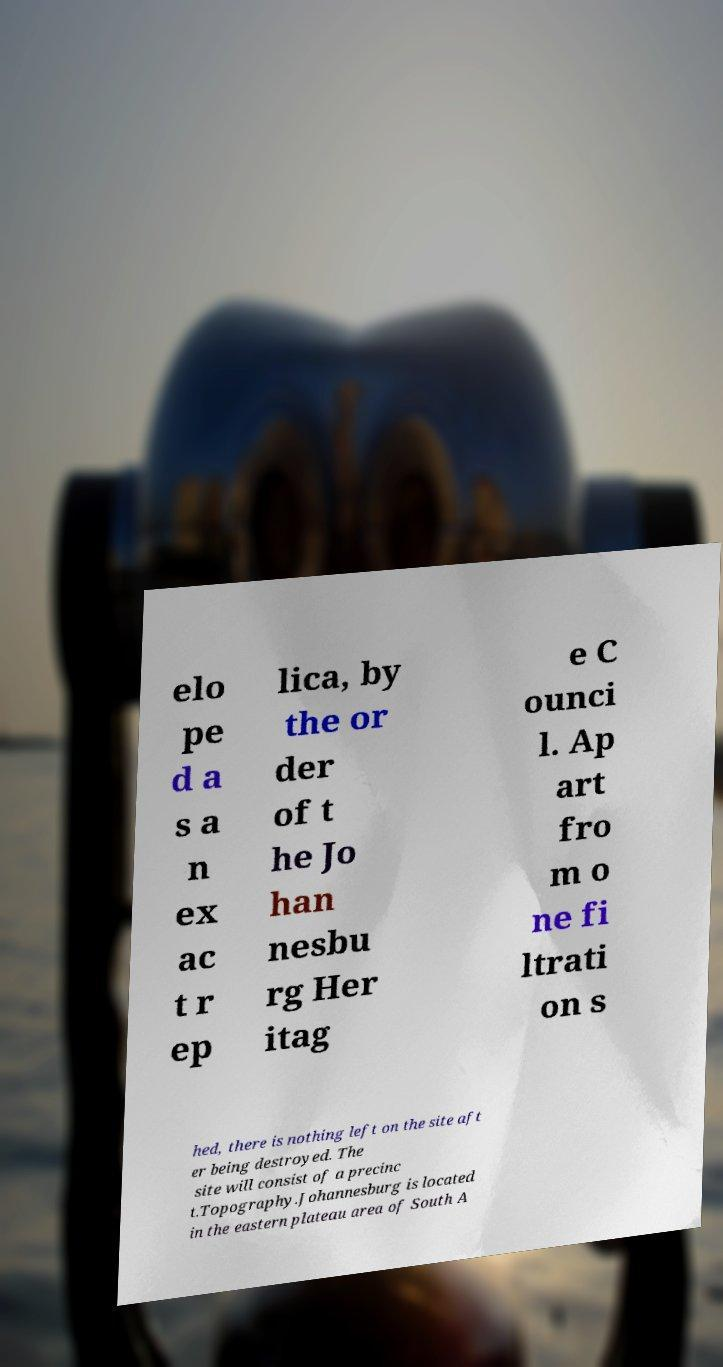What messages or text are displayed in this image? I need them in a readable, typed format. elo pe d a s a n ex ac t r ep lica, by the or der of t he Jo han nesbu rg Her itag e C ounci l. Ap art fro m o ne fi ltrati on s hed, there is nothing left on the site aft er being destroyed. The site will consist of a precinc t.Topography.Johannesburg is located in the eastern plateau area of South A 